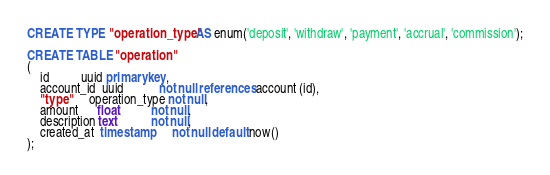Convert code to text. <code><loc_0><loc_0><loc_500><loc_500><_SQL_>
CREATE TYPE "operation_type" AS enum('deposit', 'withdraw', 'payment', 'accrual', 'commission');

CREATE TABLE "operation"
(
    id          uuid primary key,
    account_id  uuid           not null references account (id),
    "type"      operation_type not null,
    amount      float          not null,
    description text           not null,
    created_at  timestamp      not null default now()
);
</code> 